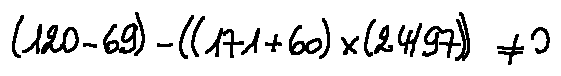Convert formula to latex. <formula><loc_0><loc_0><loc_500><loc_500>( 1 2 0 - 6 9 ) - ( ( 1 7 1 + 6 0 ) \times ( 2 4 / 9 7 ) ) \neq 0</formula> 